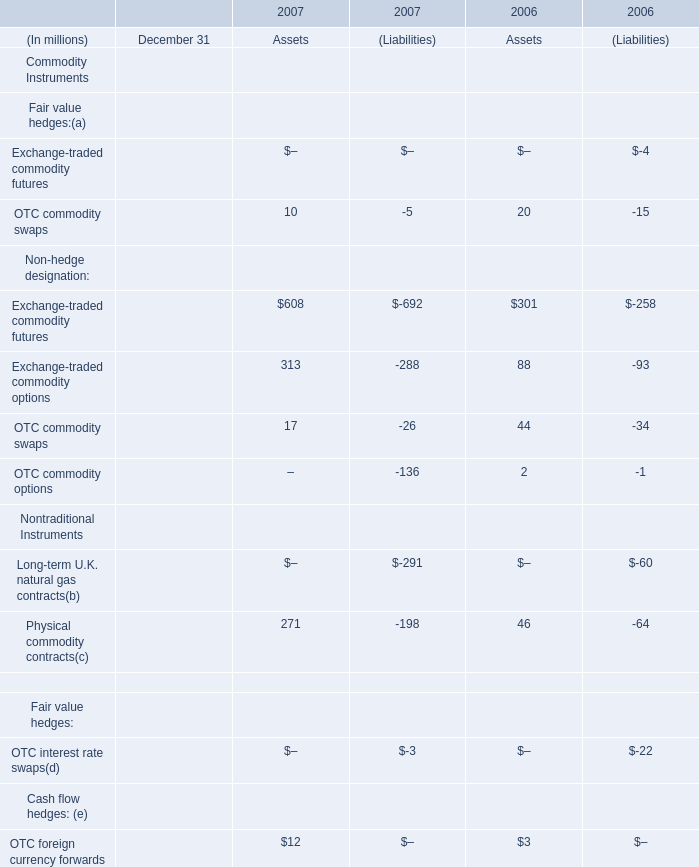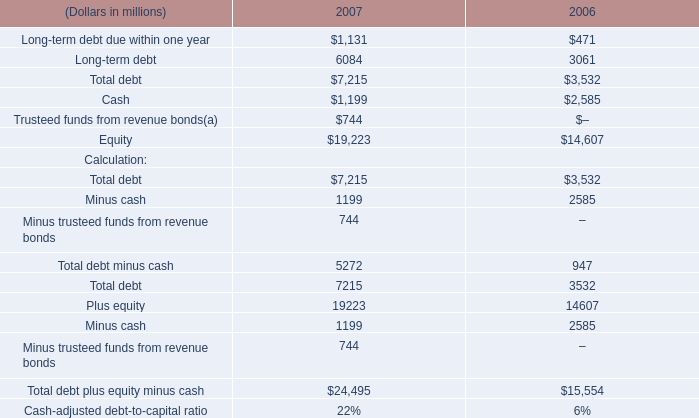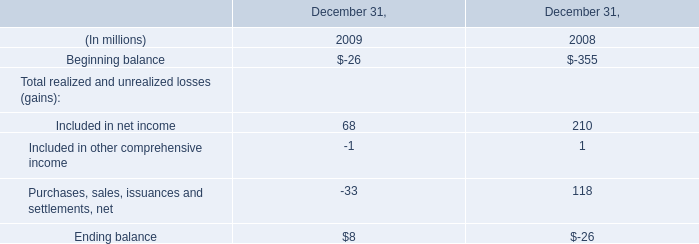What was the average value of Exchange-traded commodity futures, Exchange-traded commodity options, OTC commodity swaps in 2007 for Liabilities ? (in million) 
Computations: (((-692 - 288) - 26) / 3)
Answer: -335.33333. 